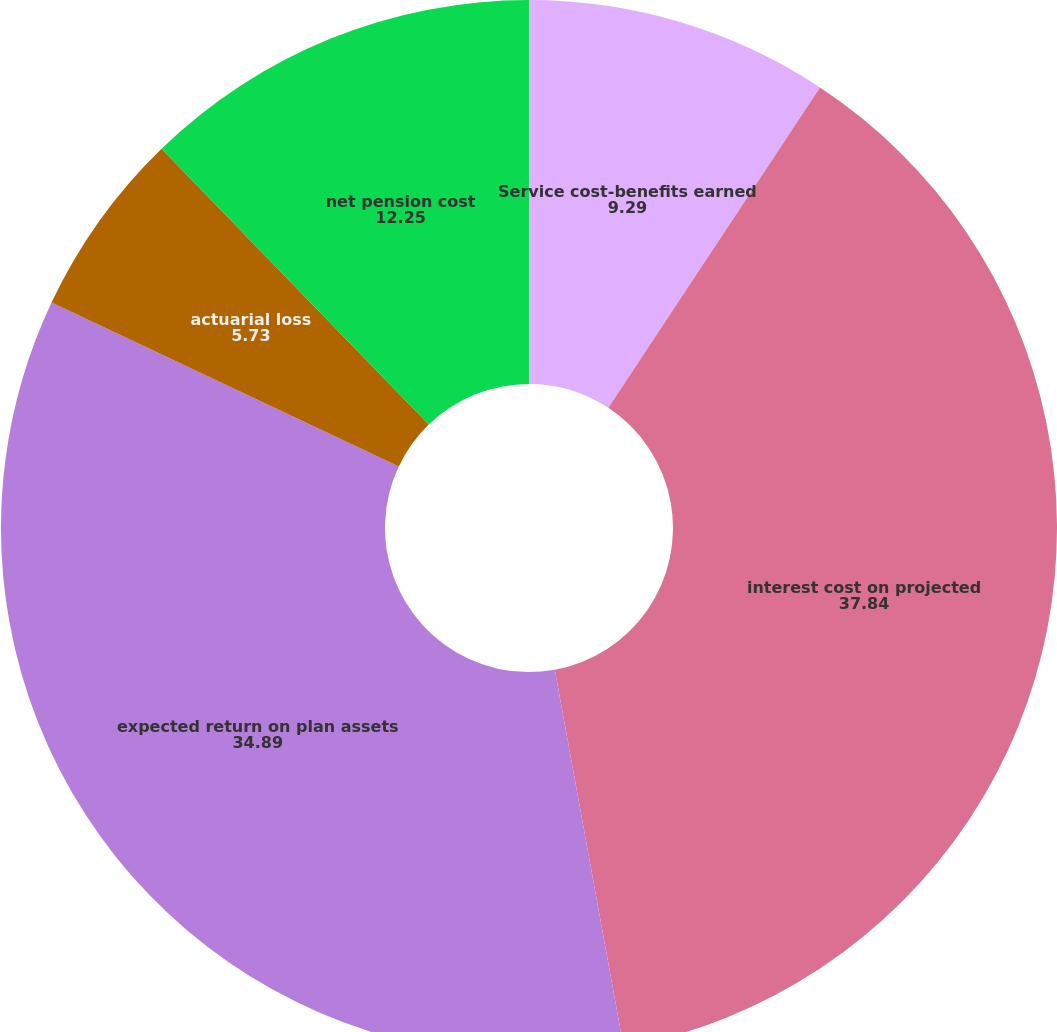Convert chart. <chart><loc_0><loc_0><loc_500><loc_500><pie_chart><fcel>Service cost-benefits earned<fcel>interest cost on projected<fcel>expected return on plan assets<fcel>actuarial loss<fcel>net pension cost<nl><fcel>9.29%<fcel>37.84%<fcel>34.89%<fcel>5.73%<fcel>12.25%<nl></chart> 